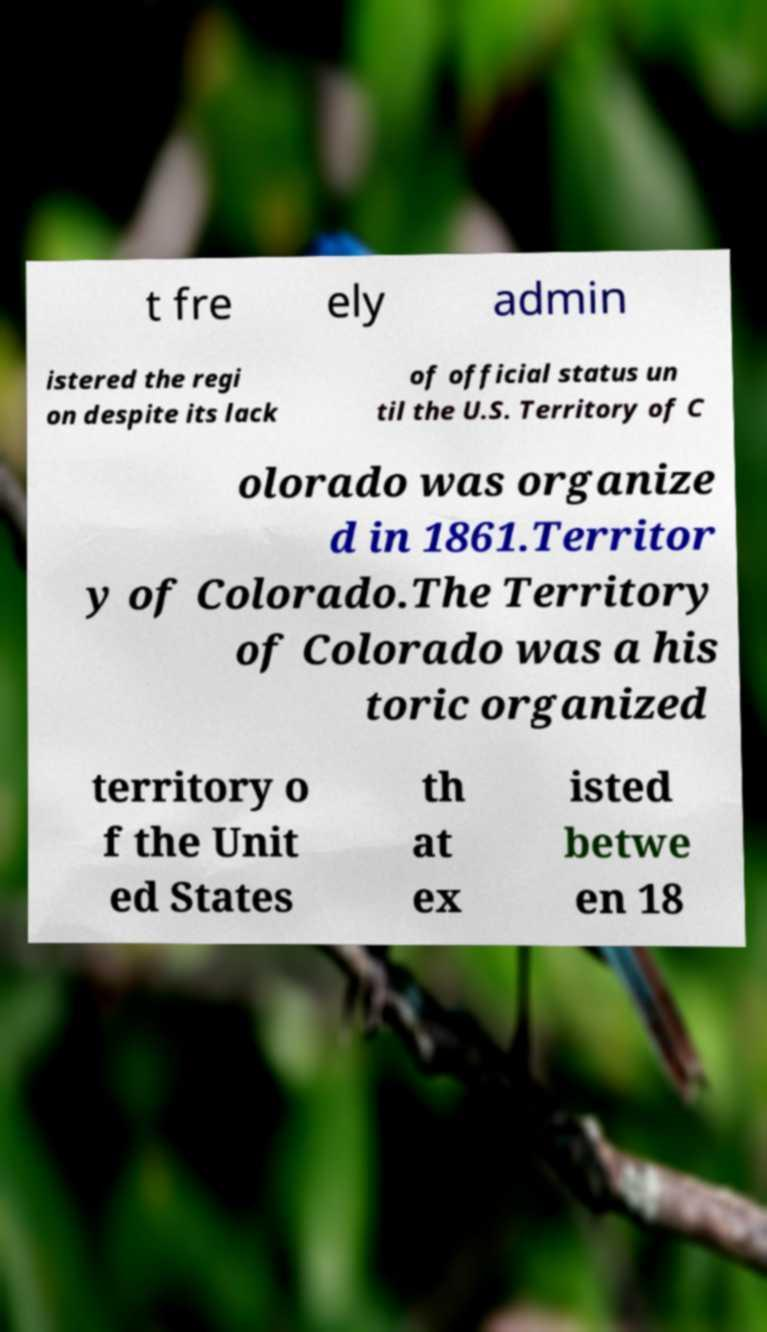What messages or text are displayed in this image? I need them in a readable, typed format. t fre ely admin istered the regi on despite its lack of official status un til the U.S. Territory of C olorado was organize d in 1861.Territor y of Colorado.The Territory of Colorado was a his toric organized territory o f the Unit ed States th at ex isted betwe en 18 